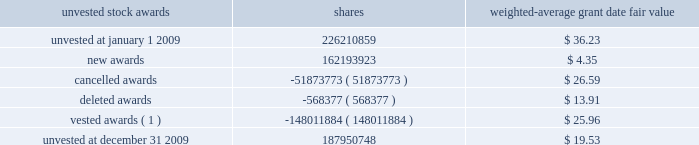Shares of citigroup common stock .
The number of shares to be delivered will equal the cse award value divided by the then fair market value of the common stock .
For cses awarded to certain employees whose compensation structure was approved by the special master , 50% ( 50 % ) of the shares to be delivered in april 2010 will be subject to restrictions on sale and transfer until january 20 , 2011 .
In lieu of 2010 cap awards , certain retirement-eligible employees were instead awarded cses payable in april 2010 , but any shares that are to be delivered in april 2010 ( subject to stockholder approval ) will be subject to restrictions on sale or transfer that will lapse in four equal annual installments beginning january 20 , 2011 .
Cse awards have generally been accrued as compensation expenses in the year 2009 and will be recorded as a liability from the january 2010 grant date until the settlement date in april 2010 .
If stockholders approve delivery of citigroup stock for the cse awards , cse awards will likely be paid as new issues of common stock as an exception to the company 2019s practice of delivering shares from treasury stock , and the recorded liability will be reclassified as equity at that time .
In january 2009 , members of the management executive committee ( except the ceo and cfo ) received 30% ( 30 % ) of their incentive awards for 2008 as performance vesting-equity awards .
These awards vest 50% ( 50 % ) if the price of citigroup common stock meets a price target of $ 10.61 , and 50% ( 50 % ) for a price target of $ 17.85 , in each case on or prior to january 14 , 2013 .
The price target will be met only if the nyse closing price equals or exceeds the applicable price target for at least 20 nyse trading days within any period of 30 consecutive nyse trading days ending on or before january 14 , 2013 .
Any shares that have not vested by such date will vest according to a fraction , the numerator of which is the share price on the delivery date and the denominator of which is the price target of the unvested shares .
No dividend equivalents are paid on unvested awards .
Fair value of the awards is recognized as compensation expense ratably over the vesting period .
On july 17 , 2007 , the committee approved the management committee long-term incentive plan ( mc ltip ) ( pursuant to the terms of the shareholder-approved 1999 stock incentive plan ) under which participants received an equity award that could be earned based on citigroup 2019s performance against various metrics relative to peer companies and publicly- stated return on equity ( roe ) targets measured at the end of each calendar year beginning with 2007 .
The final expense for each of the three consecutive calendar years was adjusted based on the results of the roe tests .
No awards were earned for 2009 , 2008 or 2007 and no shares were issued because performance targets were not met .
No new awards were made under the mc ltip since the initial award in july 2007 .
Cap participants in 2008 , 2007 , 2006 and 2005 , and fa cap participants in those years and in 2009 , could elect to receive all or part of their award in stock options .
The figures presented in the stock option program tables ( see 201cstock option programs 201d below ) include options granted in lieu of cap and fa cap stock awards in those years .
A summary of the status of citigroup 2019s unvested stock awards at december 31 , 2009 and changes during the 12 months ended december 31 , 2009 are presented below : unvested stock awards shares weighted-average grant date fair value .
( 1 ) the weighted-average market value of the vestings during 2009 was approximately $ 3.64 per share .
At december 31 , 2009 , there was $ 1.6 billion of total unrecognized compensation cost related to unvested stock awards net of the forfeiture provision .
That cost is expected to be recognized over a weighted-average period of 1.3 years. .
At december 2009 what was the annual anticipated unrecognized compensation cost related to unvested stock awards to be recognized in billions? 
Computations: (1.6 / 1.3)
Answer: 1.23077. Shares of citigroup common stock .
The number of shares to be delivered will equal the cse award value divided by the then fair market value of the common stock .
For cses awarded to certain employees whose compensation structure was approved by the special master , 50% ( 50 % ) of the shares to be delivered in april 2010 will be subject to restrictions on sale and transfer until january 20 , 2011 .
In lieu of 2010 cap awards , certain retirement-eligible employees were instead awarded cses payable in april 2010 , but any shares that are to be delivered in april 2010 ( subject to stockholder approval ) will be subject to restrictions on sale or transfer that will lapse in four equal annual installments beginning january 20 , 2011 .
Cse awards have generally been accrued as compensation expenses in the year 2009 and will be recorded as a liability from the january 2010 grant date until the settlement date in april 2010 .
If stockholders approve delivery of citigroup stock for the cse awards , cse awards will likely be paid as new issues of common stock as an exception to the company 2019s practice of delivering shares from treasury stock , and the recorded liability will be reclassified as equity at that time .
In january 2009 , members of the management executive committee ( except the ceo and cfo ) received 30% ( 30 % ) of their incentive awards for 2008 as performance vesting-equity awards .
These awards vest 50% ( 50 % ) if the price of citigroup common stock meets a price target of $ 10.61 , and 50% ( 50 % ) for a price target of $ 17.85 , in each case on or prior to january 14 , 2013 .
The price target will be met only if the nyse closing price equals or exceeds the applicable price target for at least 20 nyse trading days within any period of 30 consecutive nyse trading days ending on or before january 14 , 2013 .
Any shares that have not vested by such date will vest according to a fraction , the numerator of which is the share price on the delivery date and the denominator of which is the price target of the unvested shares .
No dividend equivalents are paid on unvested awards .
Fair value of the awards is recognized as compensation expense ratably over the vesting period .
On july 17 , 2007 , the committee approved the management committee long-term incentive plan ( mc ltip ) ( pursuant to the terms of the shareholder-approved 1999 stock incentive plan ) under which participants received an equity award that could be earned based on citigroup 2019s performance against various metrics relative to peer companies and publicly- stated return on equity ( roe ) targets measured at the end of each calendar year beginning with 2007 .
The final expense for each of the three consecutive calendar years was adjusted based on the results of the roe tests .
No awards were earned for 2009 , 2008 or 2007 and no shares were issued because performance targets were not met .
No new awards were made under the mc ltip since the initial award in july 2007 .
Cap participants in 2008 , 2007 , 2006 and 2005 , and fa cap participants in those years and in 2009 , could elect to receive all or part of their award in stock options .
The figures presented in the stock option program tables ( see 201cstock option programs 201d below ) include options granted in lieu of cap and fa cap stock awards in those years .
A summary of the status of citigroup 2019s unvested stock awards at december 31 , 2009 and changes during the 12 months ended december 31 , 2009 are presented below : unvested stock awards shares weighted-average grant date fair value .
( 1 ) the weighted-average market value of the vestings during 2009 was approximately $ 3.64 per share .
At december 31 , 2009 , there was $ 1.6 billion of total unrecognized compensation cost related to unvested stock awards net of the forfeiture provision .
That cost is expected to be recognized over a weighted-average period of 1.3 years. .
What was the approximate fair value of the shares vest in 2009? 
Rationale: the approximate fair value of the shares vest in 2009 was 538763257.76
Computations: (148011884 * 3.64)
Answer: 538763257.76. 